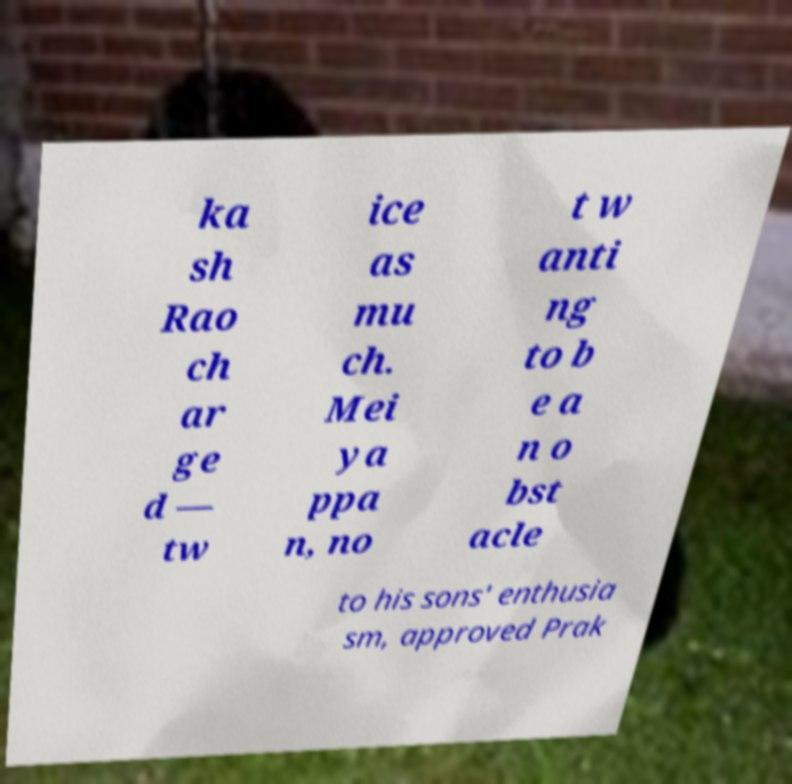Can you read and provide the text displayed in the image?This photo seems to have some interesting text. Can you extract and type it out for me? ka sh Rao ch ar ge d — tw ice as mu ch. Mei ya ppa n, no t w anti ng to b e a n o bst acle to his sons' enthusia sm, approved Prak 